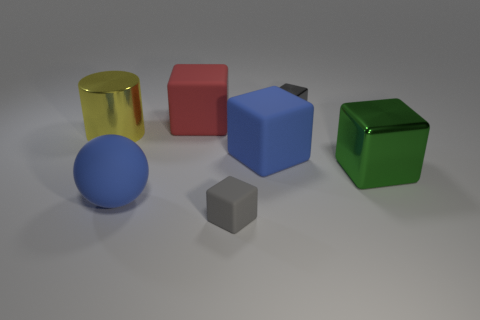Subtract all green cylinders. Subtract all green blocks. How many cylinders are left? 1 Add 3 yellow cylinders. How many objects exist? 10 Subtract all balls. How many objects are left? 6 Subtract 1 green blocks. How many objects are left? 6 Subtract all large yellow things. Subtract all big cylinders. How many objects are left? 5 Add 7 big red rubber objects. How many big red rubber objects are left? 8 Add 7 yellow metallic things. How many yellow metallic things exist? 8 